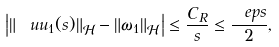<formula> <loc_0><loc_0><loc_500><loc_500>\left | \| \ u u _ { 1 } ( s ) \| _ { \mathcal { H } } - \| \omega _ { 1 } \| _ { \mathcal { H } } \right | \leq \frac { C _ { R } } { s } \leq \frac { \ e p s } { 2 } ,</formula> 